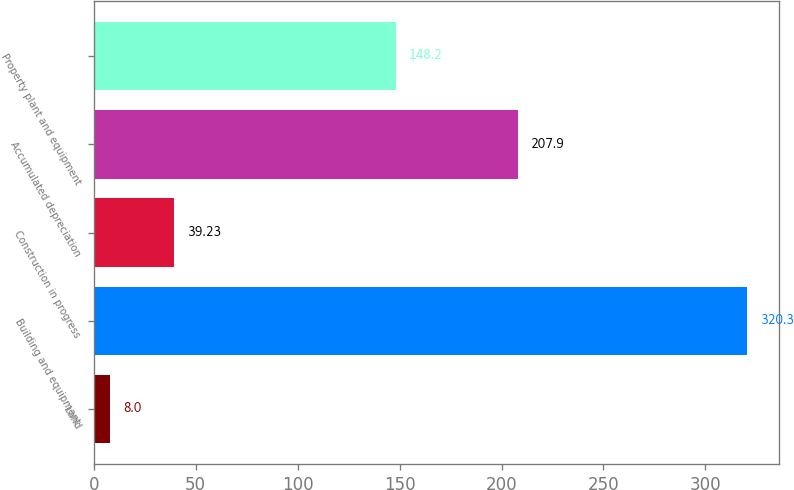Convert chart. <chart><loc_0><loc_0><loc_500><loc_500><bar_chart><fcel>Land<fcel>Building and equipment<fcel>Construction in progress<fcel>Accumulated depreciation<fcel>Property plant and equipment<nl><fcel>8<fcel>320.3<fcel>39.23<fcel>207.9<fcel>148.2<nl></chart> 